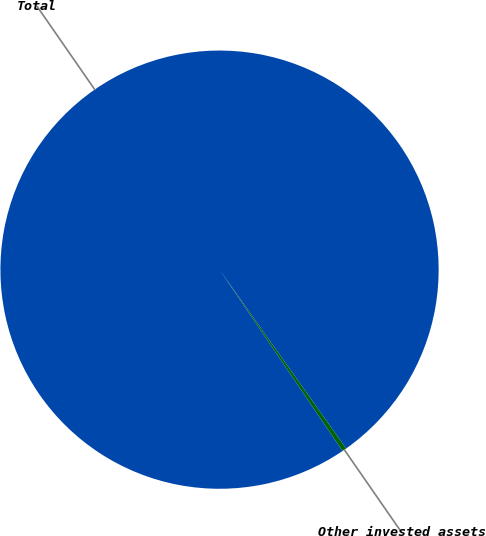Convert chart to OTSL. <chart><loc_0><loc_0><loc_500><loc_500><pie_chart><fcel>Other invested assets<fcel>Total<nl><fcel>0.32%<fcel>99.68%<nl></chart> 